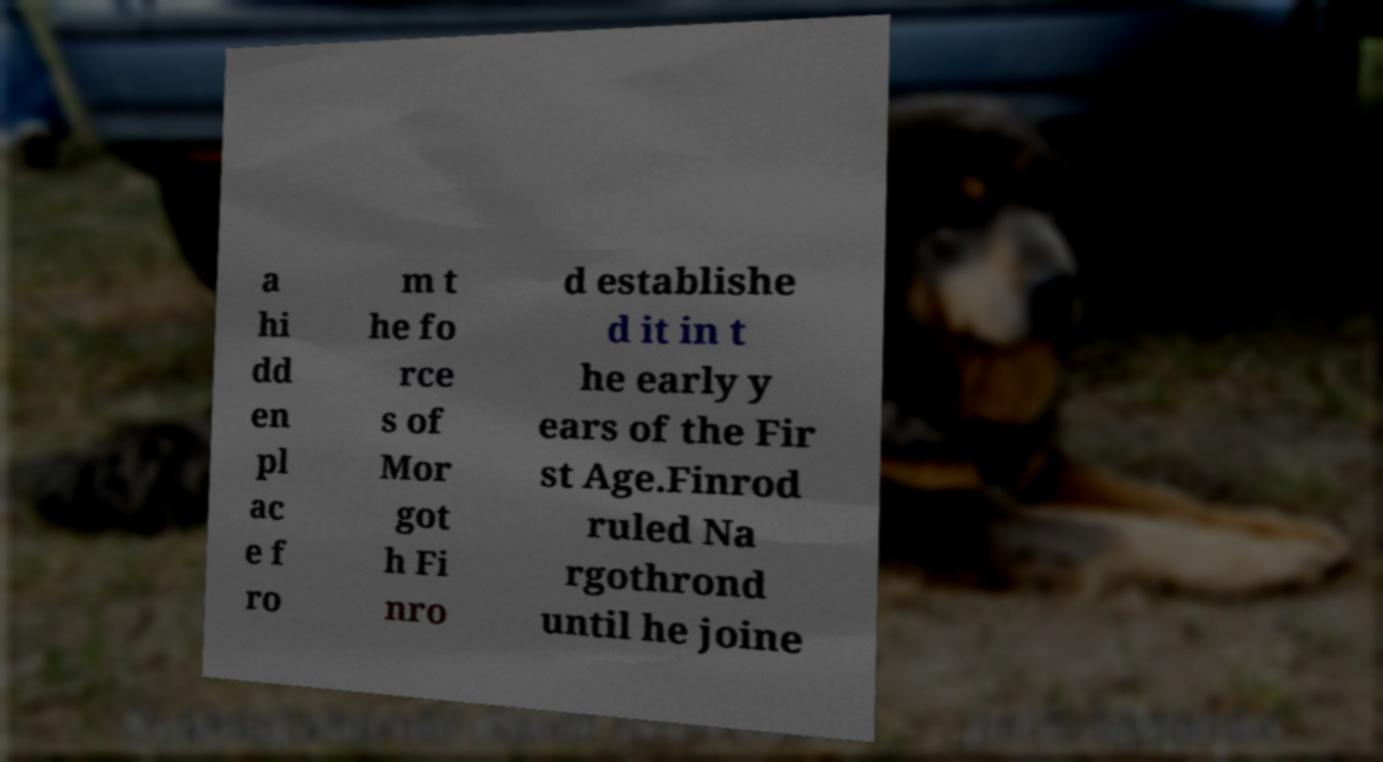Can you accurately transcribe the text from the provided image for me? a hi dd en pl ac e f ro m t he fo rce s of Mor got h Fi nro d establishe d it in t he early y ears of the Fir st Age.Finrod ruled Na rgothrond until he joine 